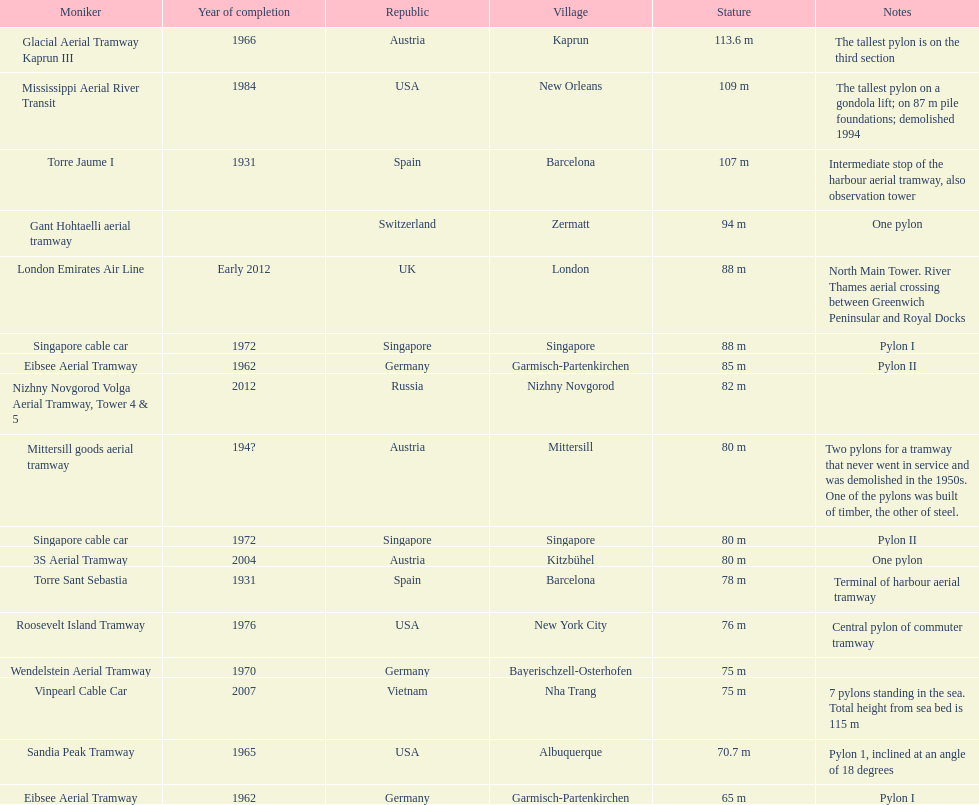Which pylon has the most remarks about it? Mittersill goods aerial tramway. 